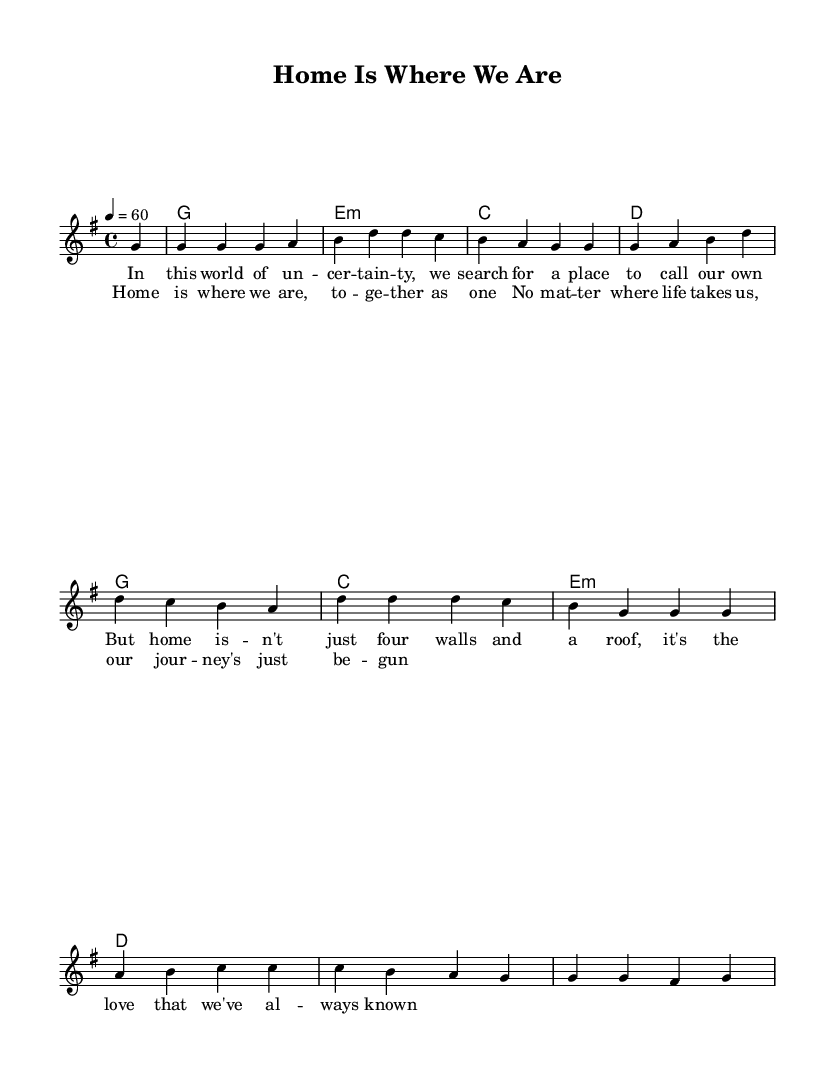What is the key signature of this music? The key signature is indicated at the beginning of the sheet music, where there are no sharps or flats shown, which confirms that it is G major.
Answer: G major What is the time signature of this music? The time signature is displayed at the beginning after the key signature. It shows four beats in each measure, indicating a 4/4 time signature.
Answer: 4/4 What is the tempo marking of this piece? The tempo marking is found at the beginning of the sheet music, stating "4 = 60," which indicates the metronome beats per minute. Thus, the piece is set to play at 60 beats per minute.
Answer: 60 How many measures are in the melody? Counting the measures in the melody section, we see there are a total of 8 distinct measures presented before the next section of lyrics.
Answer: 8 What is the first lyric line of the verse? The first line of lyrics appears just after the score heading and reads "In this world of uncertainity," representing the opening thoughts of the ballad about family.
Answer: In this world of uncertainty Which chord appears most frequently in the harmony section? Analyzing the chords given, the chord G appears at the start, and it occurs three times throughout the harmony section, making it the most repeated one.
Answer: G What is the overall theme conveyed by the lyrics? The lyrics express a feeling of togetherness and the essence of home being not just a physical space but an emotional bond shared by family members. This theme resonates deeply with the values of family unity in Rhythm and Blues.
Answer: Togetherness 